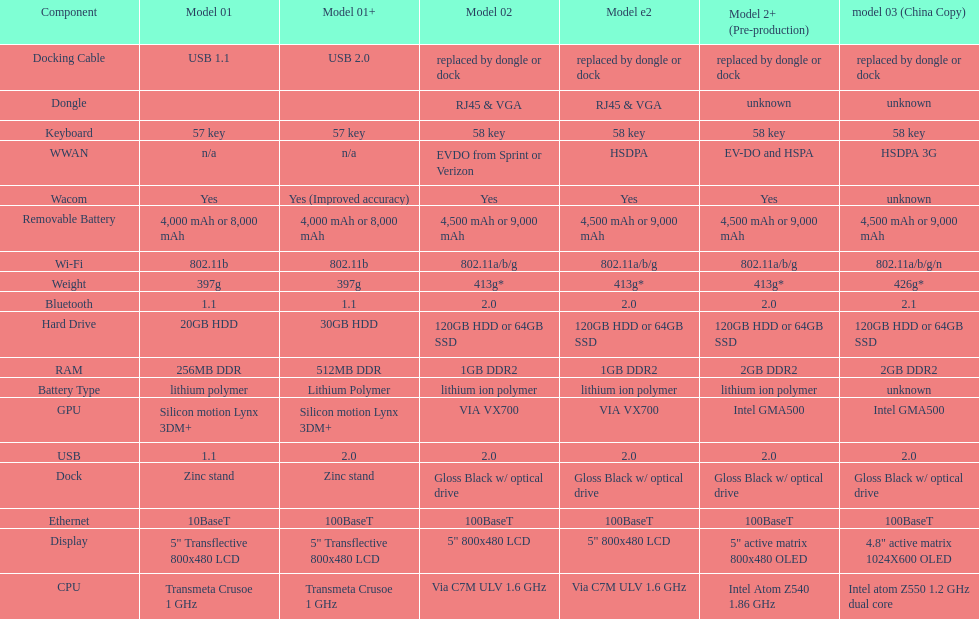How many models have 1.6ghz? 2. Could you parse the entire table as a dict? {'header': ['Component', 'Model 01', 'Model 01+', 'Model 02', 'Model e2', 'Model 2+ (Pre-production)', 'model 03 (China Copy)'], 'rows': [['Docking Cable', 'USB 1.1', 'USB 2.0', 'replaced by dongle or dock', 'replaced by dongle or dock', 'replaced by dongle or dock', 'replaced by dongle or dock'], ['Dongle', '', '', 'RJ45 & VGA', 'RJ45 & VGA', 'unknown', 'unknown'], ['Keyboard', '57 key', '57 key', '58 key', '58 key', '58 key', '58 key'], ['WWAN', 'n/a', 'n/a', 'EVDO from Sprint or Verizon', 'HSDPA', 'EV-DO and HSPA', 'HSDPA 3G'], ['Wacom', 'Yes', 'Yes (Improved accuracy)', 'Yes', 'Yes', 'Yes', 'unknown'], ['Removable Battery', '4,000 mAh or 8,000 mAh', '4,000 mAh or 8,000 mAh', '4,500 mAh or 9,000 mAh', '4,500 mAh or 9,000 mAh', '4,500 mAh or 9,000 mAh', '4,500 mAh or 9,000 mAh'], ['Wi-Fi', '802.11b', '802.11b', '802.11a/b/g', '802.11a/b/g', '802.11a/b/g', '802.11a/b/g/n'], ['Weight', '397g', '397g', '413g*', '413g*', '413g*', '426g*'], ['Bluetooth', '1.1', '1.1', '2.0', '2.0', '2.0', '2.1'], ['Hard Drive', '20GB HDD', '30GB HDD', '120GB HDD or 64GB SSD', '120GB HDD or 64GB SSD', '120GB HDD or 64GB SSD', '120GB HDD or 64GB SSD'], ['RAM', '256MB DDR', '512MB DDR', '1GB DDR2', '1GB DDR2', '2GB DDR2', '2GB DDR2'], ['Battery Type', 'lithium polymer', 'Lithium Polymer', 'lithium ion polymer', 'lithium ion polymer', 'lithium ion polymer', 'unknown'], ['GPU', 'Silicon motion Lynx 3DM+', 'Silicon motion Lynx 3DM+', 'VIA VX700', 'VIA VX700', 'Intel GMA500', 'Intel GMA500'], ['USB', '1.1', '2.0', '2.0', '2.0', '2.0', '2.0'], ['Dock', 'Zinc stand', 'Zinc stand', 'Gloss Black w/ optical drive', 'Gloss Black w/ optical drive', 'Gloss Black w/ optical drive', 'Gloss Black w/ optical drive'], ['Ethernet', '10BaseT', '100BaseT', '100BaseT', '100BaseT', '100BaseT', '100BaseT'], ['Display', '5" Transflective 800x480 LCD', '5" Transflective 800x480 LCD', '5" 800x480 LCD', '5" 800x480 LCD', '5" active matrix 800x480 OLED', '4.8" active matrix 1024X600 OLED'], ['CPU', 'Transmeta Crusoe 1\xa0GHz', 'Transmeta Crusoe 1\xa0GHz', 'Via C7M ULV 1.6\xa0GHz', 'Via C7M ULV 1.6\xa0GHz', 'Intel Atom Z540 1.86\xa0GHz', 'Intel atom Z550 1.2\xa0GHz dual core']]} 